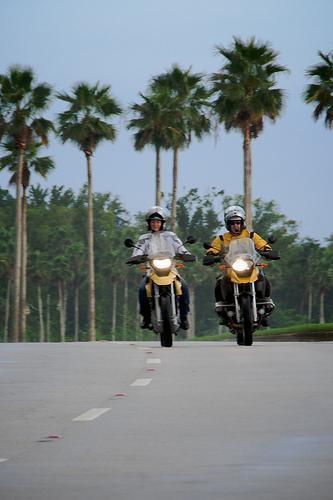How many headlights are on each bike?
Give a very brief answer. 1. 